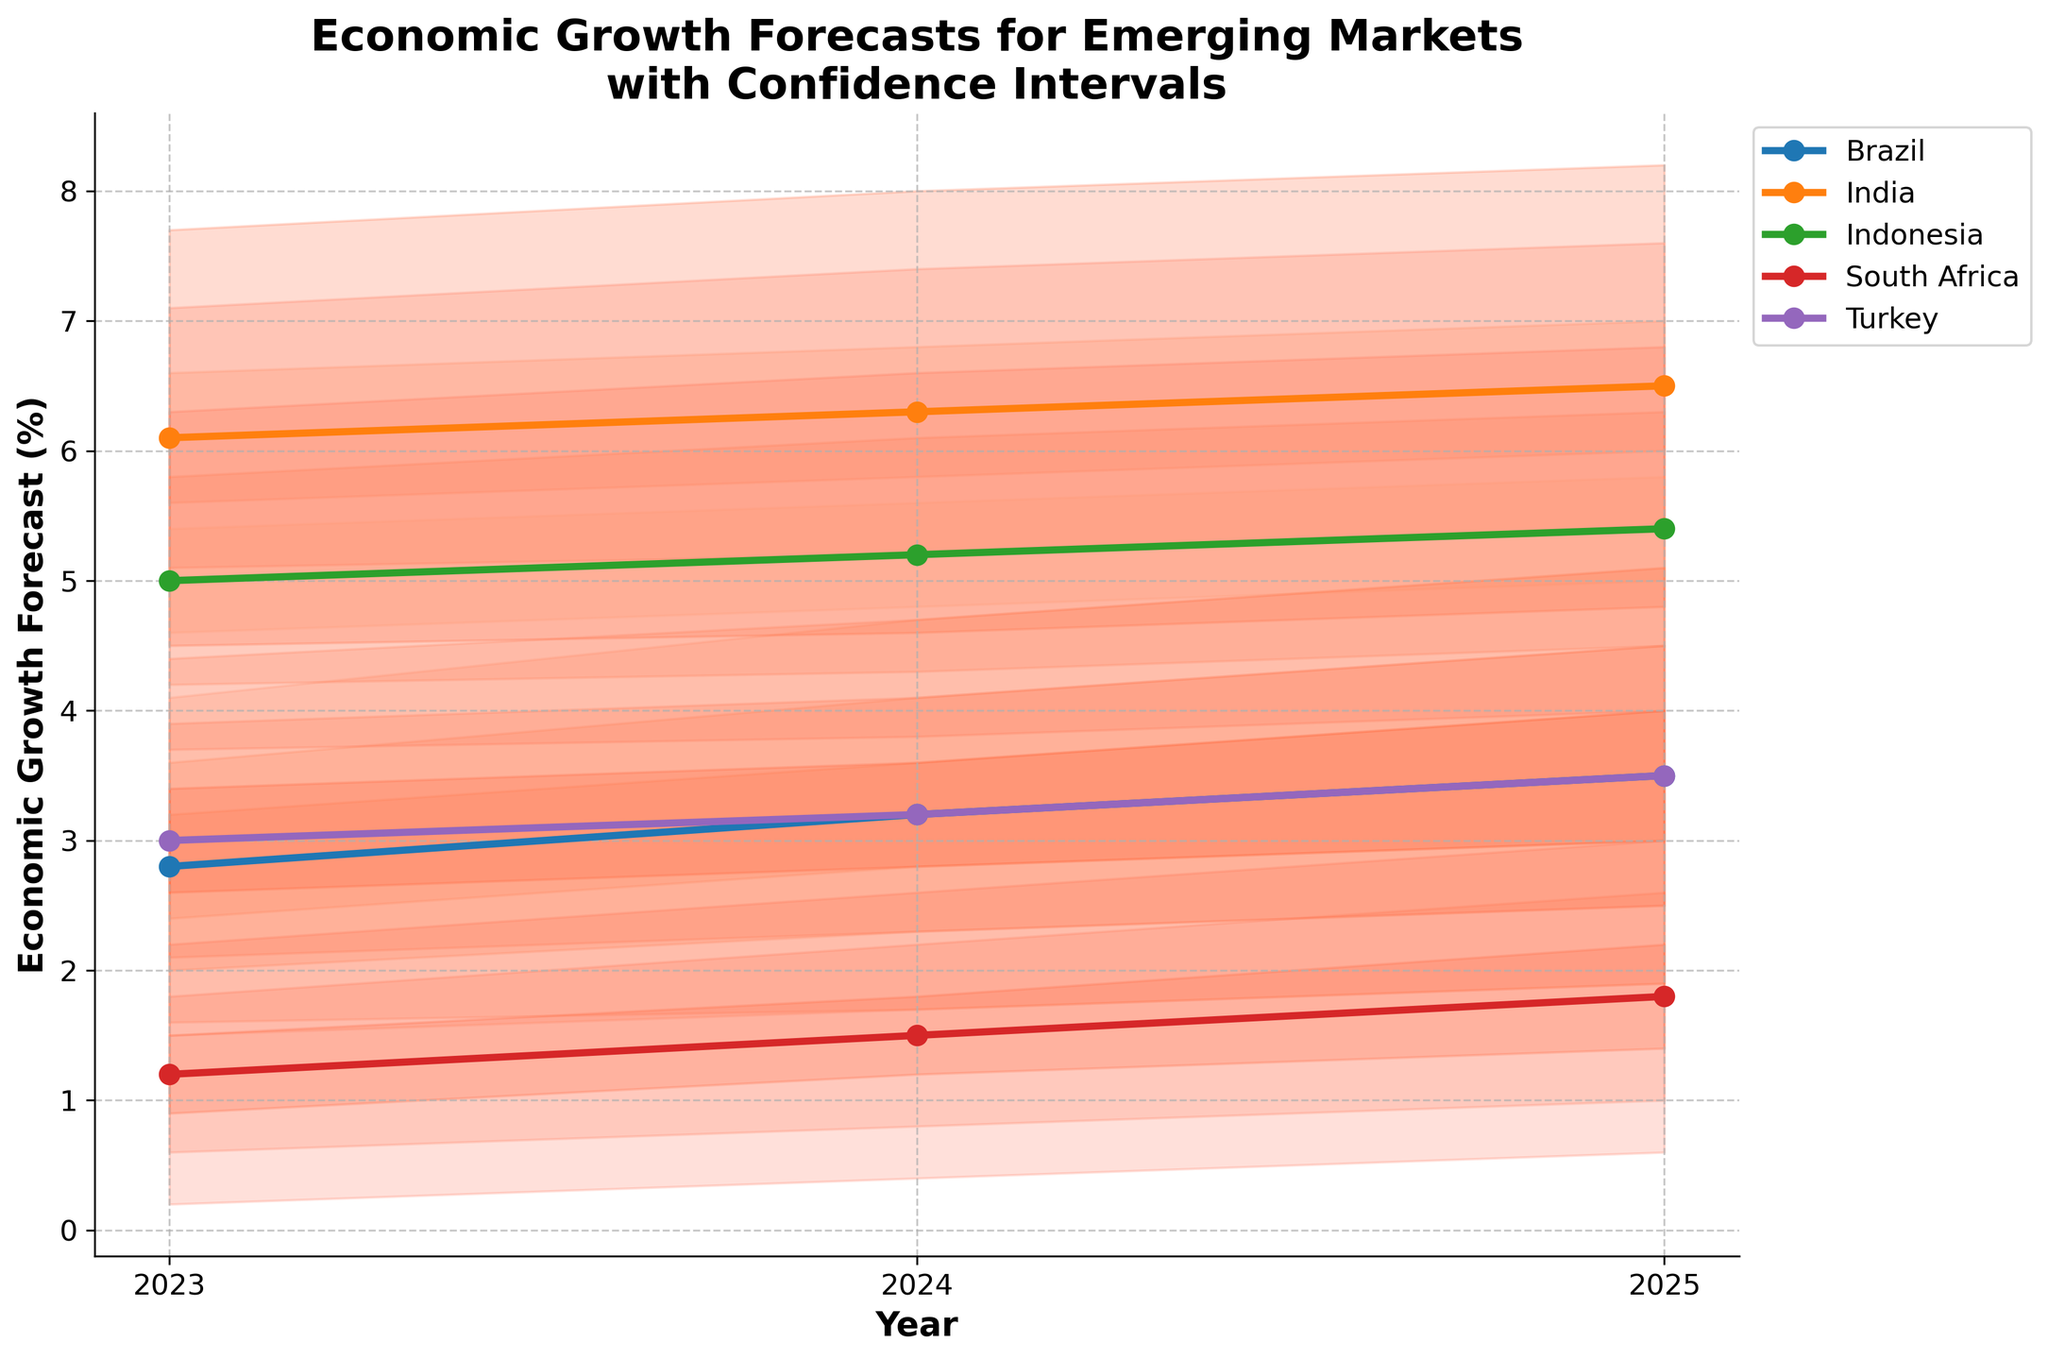What is the title of the figure? The title is a large text at the top of the figure. It summarizes the content of the plot, giving a quick understanding of what the data represents.
Answer: Economic Growth Forecasts for Emerging Markets with Confidence Intervals How many countries are represented in the figure? Count the number of unique line markers or labels in the legend on the right side of the figure. Each unique marker or label represents a different country.
Answer: 5 What is the economic growth forecast for India in 2025? Look at the intersection of India's line with the year 2025 on the x-axis and read the central forecast value from the y-axis.
Answer: 6.5% Which country has the lowest central forecast for economic growth in 2023? Compare the central forecast values for all countries in 2023 and identify the smallest value.
Answer: South Africa How does the economic forecast for Brazil change from 2023 to 2025? Look at Brazil's central forecast values in 2023 and 2025, then compute the difference to determine the change over the years.
Answer: It increases by 0.7% What are the upper 95% and lower 95% confidence intervals for Indonesia in 2024? For Indonesia in 2024, find the values marking the upper 95% and lower 95% confidence intervals from the plot where the shaded area boundaries are annotated.
Answer: Upper 95%: 6.6%, Lower 95%: 3.8% Which country has the widest confidence interval in 2023, and how wide is it? Look at the confidence intervals for each country in 2023 and calculate the width by subtracting the lower bound from the upper bound. Identify the country with the largest width.
Answer: India, 3.2% Is the economic forecast for Turkey in 2024 higher or lower than for Brazil in the same year? Compare the central forecast values for Turkey and Brazil in 2024.
Answer: Lower Between which years is the economic growth forecast for South Africa most stable? Assess the changes in South Africa's central forecast values across years and determine the period with the smallest change.
Answer: 2024 to 2025 